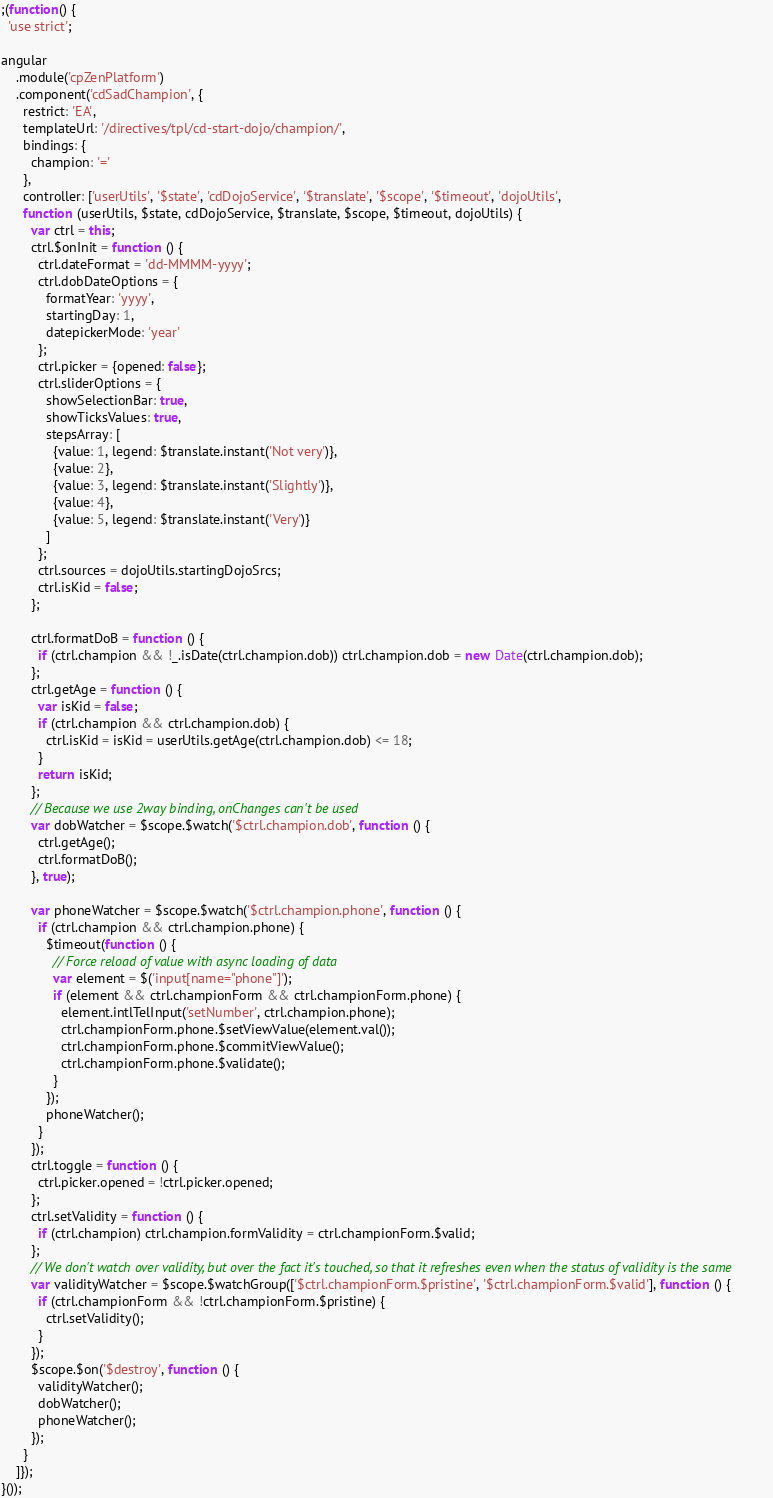<code> <loc_0><loc_0><loc_500><loc_500><_JavaScript_>;(function() {
  'use strict';

angular
    .module('cpZenPlatform')
    .component('cdSadChampion', {
      restrict: 'EA',
      templateUrl: '/directives/tpl/cd-start-dojo/champion/',
      bindings: {
        champion: '='
      },
      controller: ['userUtils', '$state', 'cdDojoService', '$translate', '$scope', '$timeout', 'dojoUtils',
      function (userUtils, $state, cdDojoService, $translate, $scope, $timeout, dojoUtils) {
        var ctrl = this;
        ctrl.$onInit = function () {
          ctrl.dateFormat = 'dd-MMMM-yyyy';
          ctrl.dobDateOptions = {
            formatYear: 'yyyy',
            startingDay: 1,
            datepickerMode: 'year'
          };
          ctrl.picker = {opened: false};
          ctrl.sliderOptions = {
            showSelectionBar: true,
            showTicksValues: true,
            stepsArray: [
              {value: 1, legend: $translate.instant('Not very')},
              {value: 2},
              {value: 3, legend: $translate.instant('Slightly')},
              {value: 4},
              {value: 5, legend: $translate.instant('Very')}
            ]
          };
          ctrl.sources = dojoUtils.startingDojoSrcs;
          ctrl.isKid = false;
        };

        ctrl.formatDoB = function () {
          if (ctrl.champion && !_.isDate(ctrl.champion.dob)) ctrl.champion.dob = new Date(ctrl.champion.dob);
        };
        ctrl.getAge = function () {
          var isKid = false;
          if (ctrl.champion && ctrl.champion.dob) {
            ctrl.isKid = isKid = userUtils.getAge(ctrl.champion.dob) <= 18;
          }
          return isKid;
        };
        // Because we use 2way binding, onChanges can't be used
        var dobWatcher = $scope.$watch('$ctrl.champion.dob', function () {
          ctrl.getAge();
          ctrl.formatDoB();
        }, true);

        var phoneWatcher = $scope.$watch('$ctrl.champion.phone', function () {
          if (ctrl.champion && ctrl.champion.phone) {
            $timeout(function () {
              // Force reload of value with async loading of data
              var element = $('input[name="phone"]');
              if (element && ctrl.championForm && ctrl.championForm.phone) {
                element.intlTelInput('setNumber', ctrl.champion.phone);
                ctrl.championForm.phone.$setViewValue(element.val());
                ctrl.championForm.phone.$commitViewValue();
                ctrl.championForm.phone.$validate();
              }
            });
            phoneWatcher();
          }
        });
        ctrl.toggle = function () {
          ctrl.picker.opened = !ctrl.picker.opened;
        };
        ctrl.setValidity = function () {
          if (ctrl.champion) ctrl.champion.formValidity = ctrl.championForm.$valid;
        };
        // We don't watch over validity, but over the fact it's touched, so that it refreshes even when the status of validity is the same
        var validityWatcher = $scope.$watchGroup(['$ctrl.championForm.$pristine', '$ctrl.championForm.$valid'], function () {
          if (ctrl.championForm && !ctrl.championForm.$pristine) {
            ctrl.setValidity();
          }
        });
        $scope.$on('$destroy', function () {
          validityWatcher();
          dobWatcher();
          phoneWatcher();
        });
      }
    ]});
}());
</code> 